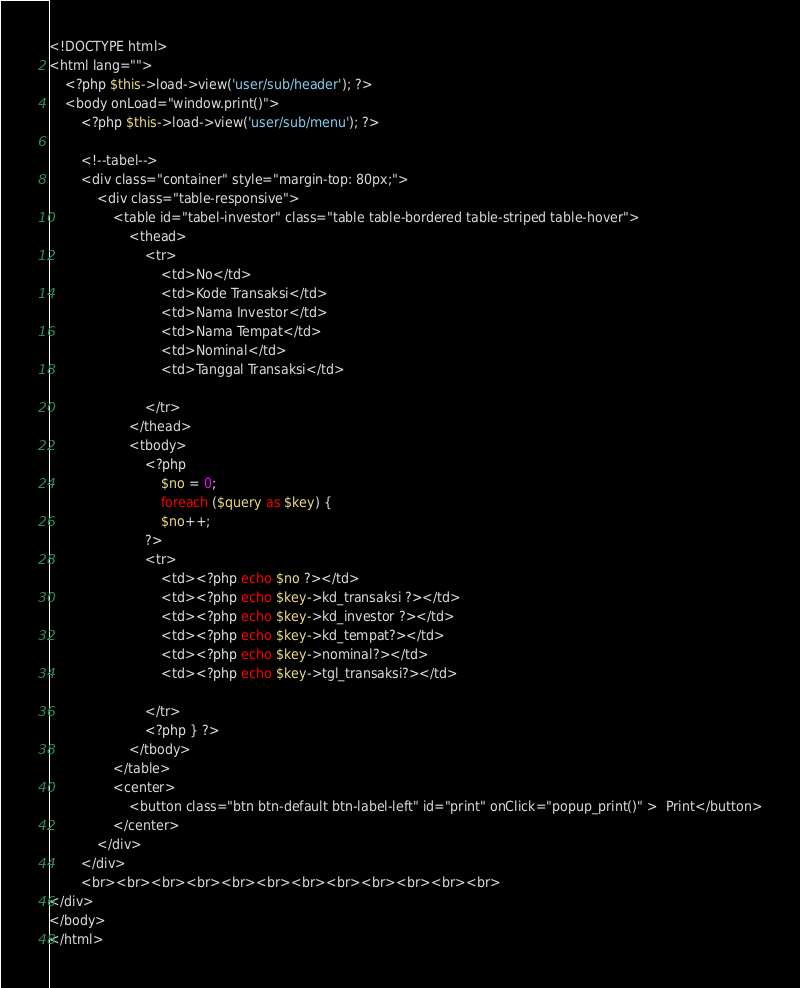Convert code to text. <code><loc_0><loc_0><loc_500><loc_500><_PHP_><!DOCTYPE html>
<html lang="">
	<?php $this->load->view('user/sub/header'); ?>
	<body onLoad="window.print()">
		<?php $this->load->view('user/sub/menu'); ?>

		<!--tabel-->
		<div class="container" style="margin-top: 80px;">
			<div class="table-responsive">
				<table id="tabel-investor" class="table table-bordered table-striped table-hover">
					<thead>
						<tr>
							<td>No</td>
							<td>Kode Transaksi</td>
							<td>Nama Investor</td>
					        <td>Nama Tempat</td>
					        <td>Nominal</td>
					        <td>Tanggal Transaksi</td>

						</tr>
					</thead>
					<tbody>
						<?php 
							$no = 0;
							foreach ($query as $key) { 
							$no++;
						?>
				  		<tr>
				  			<td><?php echo $no ?></td>
				          	<td><?php echo $key->kd_transaksi ?></td> 
				         	<td><?php echo $key->kd_investor ?></td>
				         	<td><?php echo $key->kd_tempat?></td> 
				         	<td><?php echo $key->nominal?></td> 
				           	<td><?php echo $key->tgl_transaksi?></td>            
				          	      
				        </tr>
				        <?php } ?>
					</tbody>
				</table>
				<center>
					<button class="btn btn-default btn-label-left" id="print" onClick="popup_print()" >	Print</button>
				</center>
			</div>
		</div>
		<br><br><br><br><br><br><br><br><br><br><br><br>
</div>
</body>
</html>
</code> 